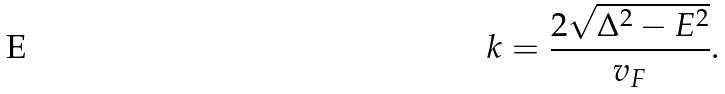<formula> <loc_0><loc_0><loc_500><loc_500>k = \frac { 2 \sqrt { \Delta ^ { 2 } - E ^ { 2 } } } { v _ { F } } .</formula> 